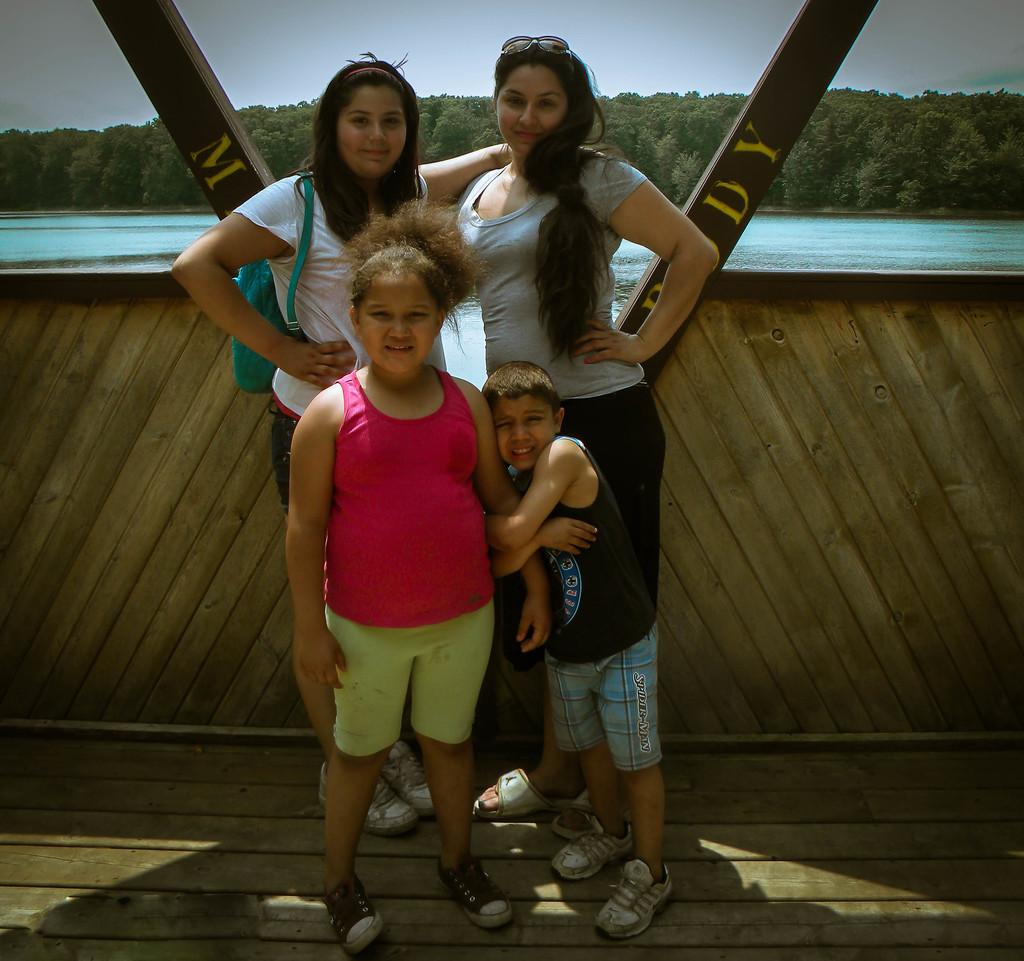How many people are in the image? There are four people in the image. What is the position of the people in the image? The people are on the ground. What can be seen in the background of the image? There is a fence, water, trees, and the sky visible in the background of the image. What type of body of water is visible in the image? There is no body of water visible in the image; only water is mentioned in the background. Can you tell me how many friends are present in the image? The term "friend" is not mentioned in the facts provided, so it is not possible to determine the number of friends in the image. 